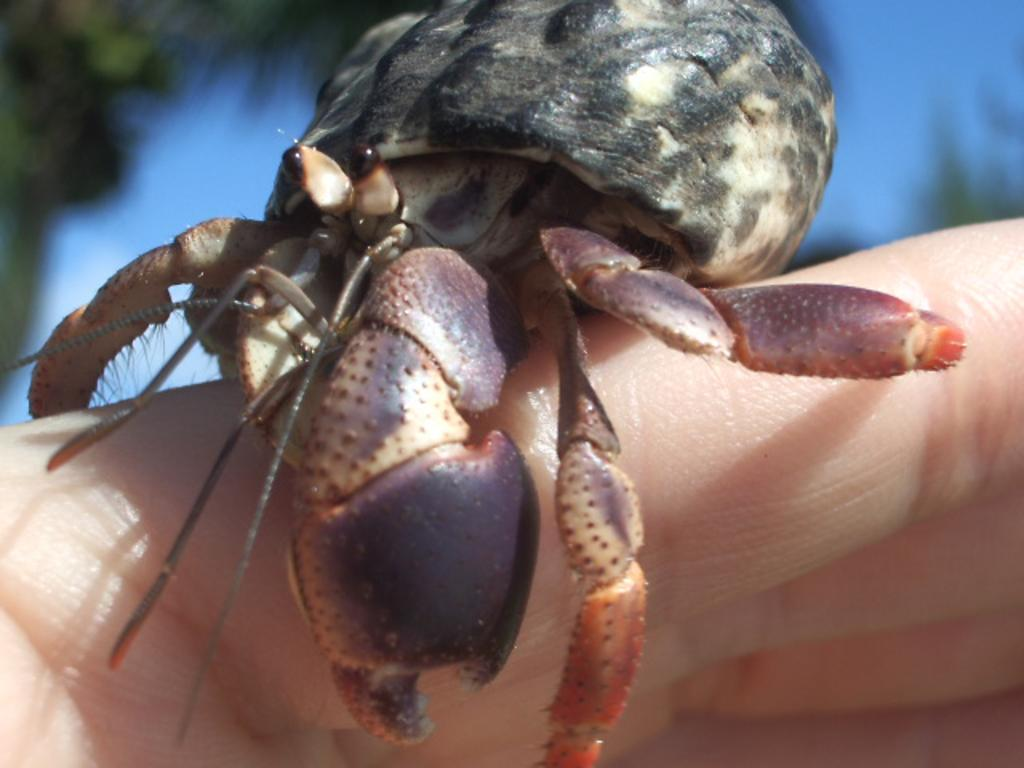What is on the fingers in the image? There is a crab on the fingers in the image. What can be observed about the background of the image? The background of the image is blurred. What part of the natural environment is visible in the image? The sky is visible in the image. What word is written on the tree in the image? There is no tree or word present in the image; it features a crab on the fingers with a blurred background and visible sky. 